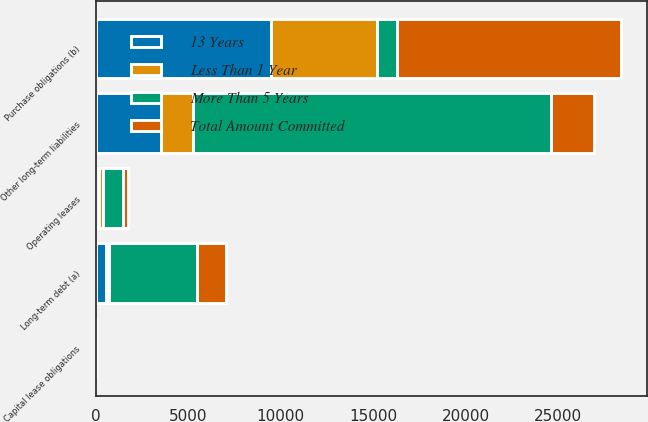Convert chart. <chart><loc_0><loc_0><loc_500><loc_500><stacked_bar_chart><ecel><fcel>Long-term debt (a)<fcel>Capital lease obligations<fcel>Operating leases<fcel>Purchase obligations (b)<fcel>Other long-term liabilities<nl><fcel>More Than 5 Years<fcel>4771<fcel>31<fcel>1078<fcel>1078<fcel>19358<nl><fcel>13 Years<fcel>586<fcel>2<fcel>210<fcel>9482<fcel>3554<nl><fcel>Total Amount Committed<fcel>1549<fcel>4<fcel>313<fcel>12090<fcel>2330<nl><fcel>Less Than 1 Year<fcel>122<fcel>4<fcel>172<fcel>5757<fcel>1705<nl></chart> 